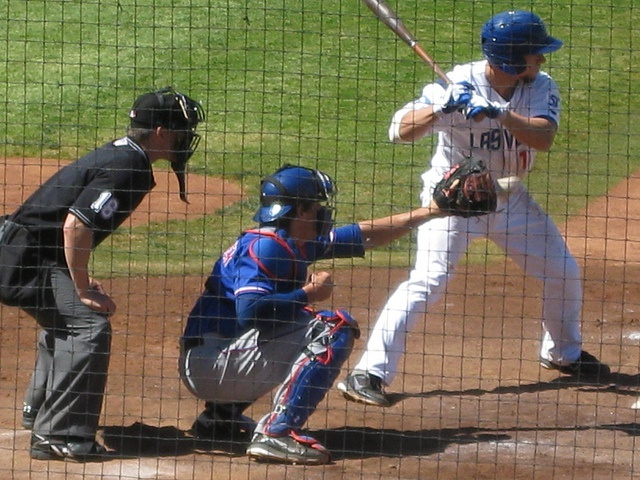Describe the objects in this image and their specific colors. I can see people in olive, black, gray, navy, and maroon tones, people in olive, gray, white, and black tones, people in olive, black, gray, and maroon tones, baseball glove in olive, black, gray, and maroon tones, and baseball bat in olive, gray, darkgreen, and darkgray tones in this image. 